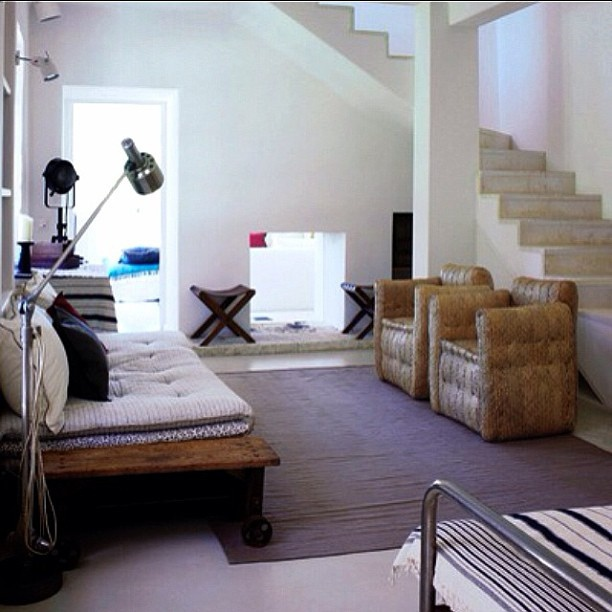Describe the objects in this image and their specific colors. I can see couch in black, darkgray, maroon, and lavender tones, chair in black, maroon, and gray tones, couch in black, darkgray, gray, and lavender tones, bed in black, darkgray, lavender, and gray tones, and chair in black, gray, and maroon tones in this image. 